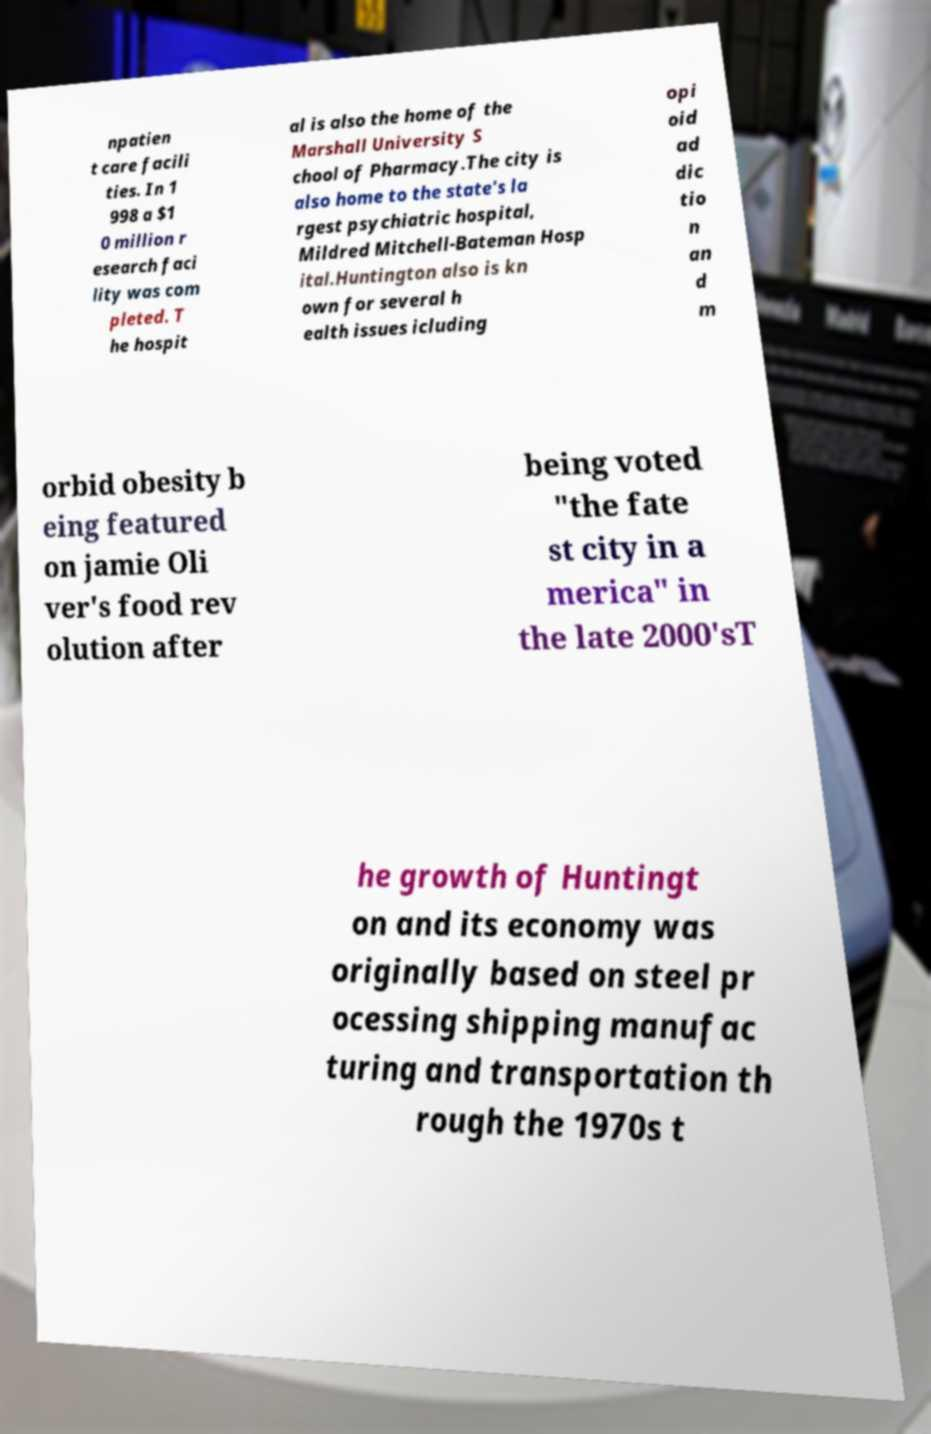Could you extract and type out the text from this image? npatien t care facili ties. In 1 998 a $1 0 million r esearch faci lity was com pleted. T he hospit al is also the home of the Marshall University S chool of Pharmacy.The city is also home to the state's la rgest psychiatric hospital, Mildred Mitchell-Bateman Hosp ital.Huntington also is kn own for several h ealth issues icluding opi oid ad dic tio n an d m orbid obesity b eing featured on jamie Oli ver's food rev olution after being voted "the fate st city in a merica" in the late 2000'sT he growth of Huntingt on and its economy was originally based on steel pr ocessing shipping manufac turing and transportation th rough the 1970s t 